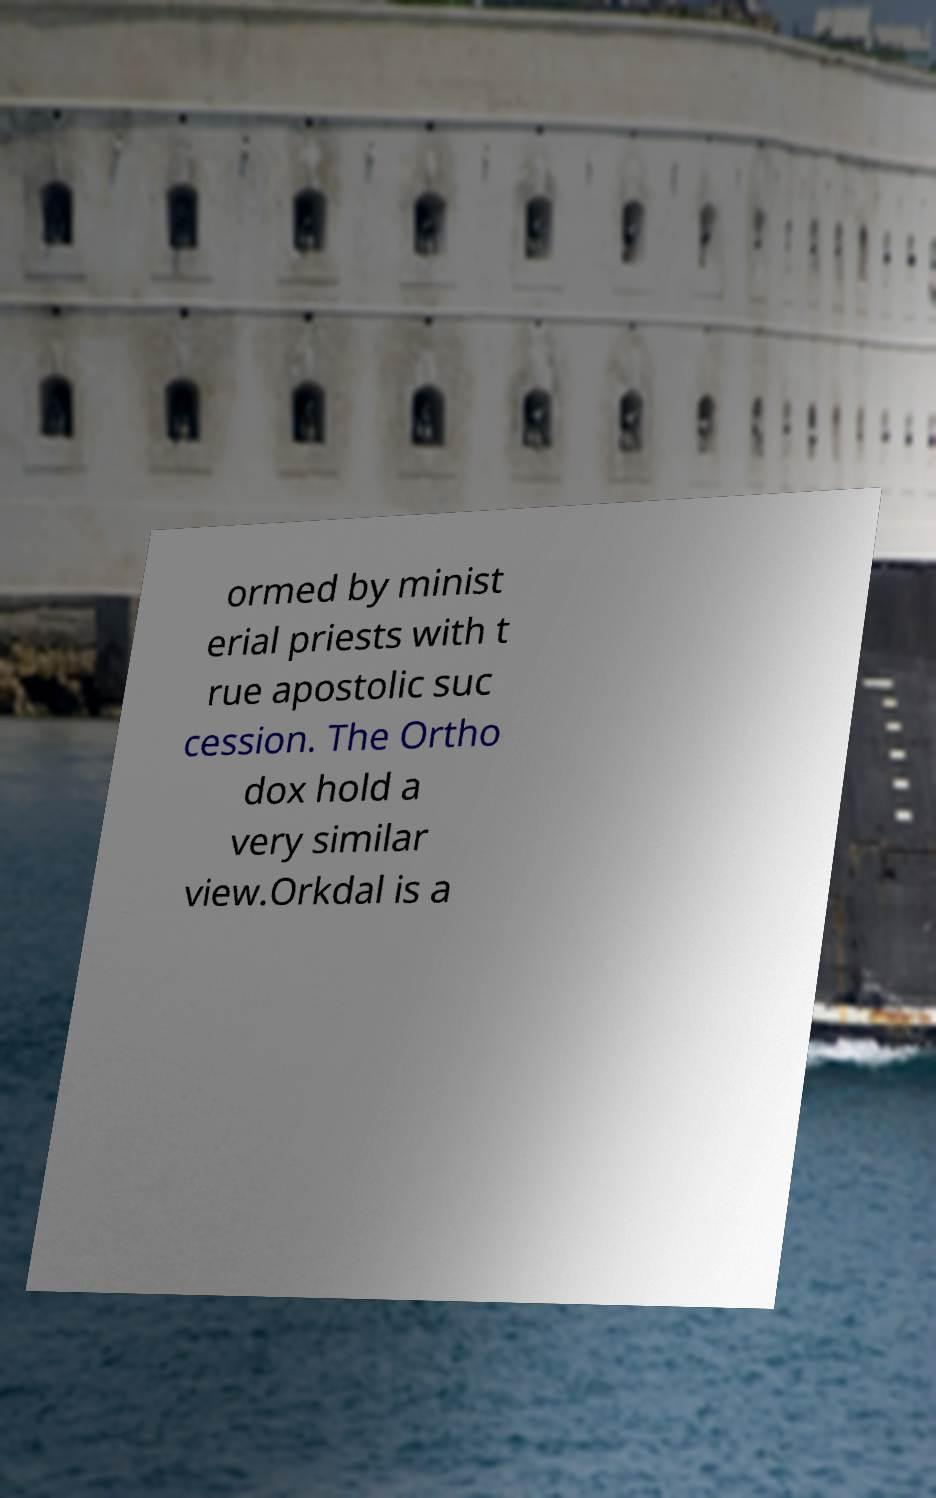What messages or text are displayed in this image? I need them in a readable, typed format. ormed by minist erial priests with t rue apostolic suc cession. The Ortho dox hold a very similar view.Orkdal is a 